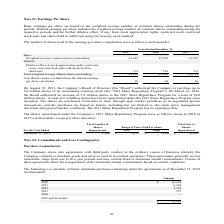According to Sykes Enterprises Incorporated's financial document, What is the number of Basic Weighted average common shares outstanding in 2019? According to the financial document, 41,649 (in thousands). The relevant text states: "Weighted average common shares outstanding 41,649 42,090 41,822..." Also, What is the number of Total weighted average diluted shares outstanding in 2018? According to the financial document, 42,246 (in thousands). The relevant text states: "eighted average diluted shares outstanding 41,802 42,246 42,141..." Also, In which years is the Total weighted average diluted shares outstanding calculated? The document contains multiple relevant values: 2019, 2018, 2017. From the document: "2019 2018 2017 2019 2018 2017 2019 2018 2017..." Additionally, In which year was the Anti-dilutive shares excluded from the diluted earnings per share calculation largest? According to the financial document, 2019. The relevant text states: "2019 2018 2017..." Also, can you calculate: What was the change in the Anti-dilutive shares excluded from the diluted earnings per share calculation in 2019 from 2018? Based on the calculation: 69-44, the result is 25 (in thousands). This is based on the information: "d from the diluted earnings per share calculation 69 44 46 rom the diluted earnings per share calculation 69 44 46..." The key data points involved are: 44, 69. Also, can you calculate: What was the percentage change in the Anti-dilutive shares excluded from the diluted earnings per share calculation in 2019 from 2018? To answer this question, I need to perform calculations using the financial data. The calculation is: (69-44)/44, which equals 56.82 (percentage). This is based on the information: "d from the diluted earnings per share calculation 69 44 46 rom the diluted earnings per share calculation 69 44 46..." The key data points involved are: 44, 69. 